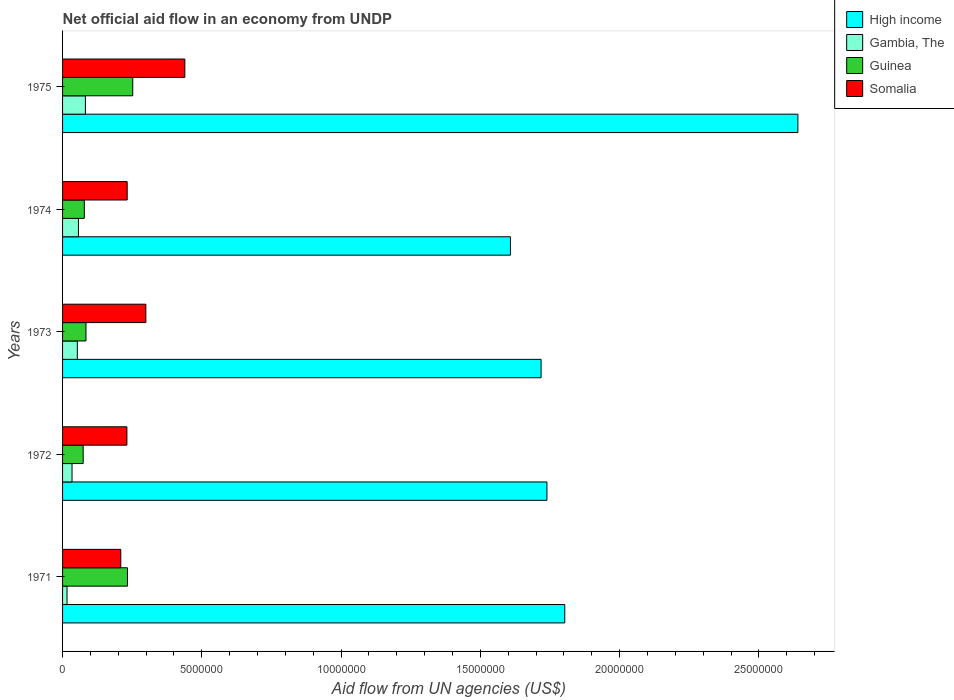How many different coloured bars are there?
Make the answer very short. 4. How many groups of bars are there?
Provide a short and direct response. 5. What is the label of the 5th group of bars from the top?
Ensure brevity in your answer.  1971. In how many cases, is the number of bars for a given year not equal to the number of legend labels?
Offer a very short reply. 0. What is the net official aid flow in Gambia, The in 1974?
Ensure brevity in your answer.  5.70e+05. Across all years, what is the maximum net official aid flow in Somalia?
Ensure brevity in your answer.  4.39e+06. Across all years, what is the minimum net official aid flow in Somalia?
Your answer should be compact. 2.09e+06. In which year was the net official aid flow in Somalia maximum?
Make the answer very short. 1975. What is the total net official aid flow in Guinea in the graph?
Keep it short and to the point. 7.21e+06. What is the difference between the net official aid flow in Guinea in 1972 and that in 1973?
Your answer should be compact. -1.00e+05. What is the difference between the net official aid flow in Somalia in 1973 and the net official aid flow in Gambia, The in 1972?
Give a very brief answer. 2.65e+06. What is the average net official aid flow in High income per year?
Keep it short and to the point. 1.90e+07. In the year 1975, what is the difference between the net official aid flow in Somalia and net official aid flow in Gambia, The?
Offer a very short reply. 3.57e+06. In how many years, is the net official aid flow in Gambia, The greater than 2000000 US$?
Keep it short and to the point. 0. What is the ratio of the net official aid flow in High income in 1972 to that in 1974?
Provide a short and direct response. 1.08. Is the net official aid flow in Guinea in 1972 less than that in 1973?
Make the answer very short. Yes. What is the difference between the highest and the second highest net official aid flow in Somalia?
Your answer should be very brief. 1.40e+06. What is the difference between the highest and the lowest net official aid flow in Gambia, The?
Give a very brief answer. 6.60e+05. Is the sum of the net official aid flow in Gambia, The in 1971 and 1972 greater than the maximum net official aid flow in Somalia across all years?
Offer a terse response. No. Is it the case that in every year, the sum of the net official aid flow in Gambia, The and net official aid flow in High income is greater than the sum of net official aid flow in Guinea and net official aid flow in Somalia?
Your response must be concise. Yes. What does the 3rd bar from the top in 1975 represents?
Your answer should be compact. Gambia, The. What does the 3rd bar from the bottom in 1973 represents?
Your answer should be compact. Guinea. Are all the bars in the graph horizontal?
Give a very brief answer. Yes. What is the difference between two consecutive major ticks on the X-axis?
Ensure brevity in your answer.  5.00e+06. Are the values on the major ticks of X-axis written in scientific E-notation?
Offer a very short reply. No. Does the graph contain any zero values?
Provide a short and direct response. No. What is the title of the graph?
Your answer should be very brief. Net official aid flow in an economy from UNDP. What is the label or title of the X-axis?
Provide a succinct answer. Aid flow from UN agencies (US$). What is the Aid flow from UN agencies (US$) of High income in 1971?
Provide a succinct answer. 1.80e+07. What is the Aid flow from UN agencies (US$) in Guinea in 1971?
Your answer should be compact. 2.33e+06. What is the Aid flow from UN agencies (US$) of Somalia in 1971?
Provide a short and direct response. 2.09e+06. What is the Aid flow from UN agencies (US$) of High income in 1972?
Offer a terse response. 1.74e+07. What is the Aid flow from UN agencies (US$) in Guinea in 1972?
Give a very brief answer. 7.40e+05. What is the Aid flow from UN agencies (US$) in Somalia in 1972?
Provide a succinct answer. 2.31e+06. What is the Aid flow from UN agencies (US$) in High income in 1973?
Your answer should be very brief. 1.72e+07. What is the Aid flow from UN agencies (US$) of Gambia, The in 1973?
Give a very brief answer. 5.30e+05. What is the Aid flow from UN agencies (US$) in Guinea in 1973?
Give a very brief answer. 8.40e+05. What is the Aid flow from UN agencies (US$) in Somalia in 1973?
Your answer should be compact. 2.99e+06. What is the Aid flow from UN agencies (US$) in High income in 1974?
Ensure brevity in your answer.  1.61e+07. What is the Aid flow from UN agencies (US$) of Gambia, The in 1974?
Offer a very short reply. 5.70e+05. What is the Aid flow from UN agencies (US$) of Guinea in 1974?
Give a very brief answer. 7.80e+05. What is the Aid flow from UN agencies (US$) of Somalia in 1974?
Offer a very short reply. 2.32e+06. What is the Aid flow from UN agencies (US$) in High income in 1975?
Offer a terse response. 2.64e+07. What is the Aid flow from UN agencies (US$) of Gambia, The in 1975?
Ensure brevity in your answer.  8.20e+05. What is the Aid flow from UN agencies (US$) of Guinea in 1975?
Keep it short and to the point. 2.52e+06. What is the Aid flow from UN agencies (US$) in Somalia in 1975?
Your answer should be very brief. 4.39e+06. Across all years, what is the maximum Aid flow from UN agencies (US$) in High income?
Give a very brief answer. 2.64e+07. Across all years, what is the maximum Aid flow from UN agencies (US$) in Gambia, The?
Provide a succinct answer. 8.20e+05. Across all years, what is the maximum Aid flow from UN agencies (US$) in Guinea?
Provide a short and direct response. 2.52e+06. Across all years, what is the maximum Aid flow from UN agencies (US$) in Somalia?
Offer a very short reply. 4.39e+06. Across all years, what is the minimum Aid flow from UN agencies (US$) in High income?
Make the answer very short. 1.61e+07. Across all years, what is the minimum Aid flow from UN agencies (US$) of Guinea?
Give a very brief answer. 7.40e+05. Across all years, what is the minimum Aid flow from UN agencies (US$) of Somalia?
Ensure brevity in your answer.  2.09e+06. What is the total Aid flow from UN agencies (US$) of High income in the graph?
Give a very brief answer. 9.51e+07. What is the total Aid flow from UN agencies (US$) of Gambia, The in the graph?
Provide a short and direct response. 2.42e+06. What is the total Aid flow from UN agencies (US$) in Guinea in the graph?
Your answer should be very brief. 7.21e+06. What is the total Aid flow from UN agencies (US$) of Somalia in the graph?
Offer a terse response. 1.41e+07. What is the difference between the Aid flow from UN agencies (US$) of High income in 1971 and that in 1972?
Your answer should be compact. 6.40e+05. What is the difference between the Aid flow from UN agencies (US$) of Guinea in 1971 and that in 1972?
Your answer should be very brief. 1.59e+06. What is the difference between the Aid flow from UN agencies (US$) of Somalia in 1971 and that in 1972?
Your answer should be very brief. -2.20e+05. What is the difference between the Aid flow from UN agencies (US$) of High income in 1971 and that in 1973?
Offer a very short reply. 8.50e+05. What is the difference between the Aid flow from UN agencies (US$) of Gambia, The in 1971 and that in 1973?
Your answer should be compact. -3.70e+05. What is the difference between the Aid flow from UN agencies (US$) in Guinea in 1971 and that in 1973?
Your answer should be very brief. 1.49e+06. What is the difference between the Aid flow from UN agencies (US$) in Somalia in 1971 and that in 1973?
Your answer should be very brief. -9.00e+05. What is the difference between the Aid flow from UN agencies (US$) in High income in 1971 and that in 1974?
Your response must be concise. 1.95e+06. What is the difference between the Aid flow from UN agencies (US$) of Gambia, The in 1971 and that in 1974?
Offer a very short reply. -4.10e+05. What is the difference between the Aid flow from UN agencies (US$) in Guinea in 1971 and that in 1974?
Provide a succinct answer. 1.55e+06. What is the difference between the Aid flow from UN agencies (US$) in High income in 1971 and that in 1975?
Keep it short and to the point. -8.37e+06. What is the difference between the Aid flow from UN agencies (US$) of Gambia, The in 1971 and that in 1975?
Make the answer very short. -6.60e+05. What is the difference between the Aid flow from UN agencies (US$) of Guinea in 1971 and that in 1975?
Your response must be concise. -1.90e+05. What is the difference between the Aid flow from UN agencies (US$) in Somalia in 1971 and that in 1975?
Keep it short and to the point. -2.30e+06. What is the difference between the Aid flow from UN agencies (US$) of High income in 1972 and that in 1973?
Give a very brief answer. 2.10e+05. What is the difference between the Aid flow from UN agencies (US$) of Gambia, The in 1972 and that in 1973?
Make the answer very short. -1.90e+05. What is the difference between the Aid flow from UN agencies (US$) in Guinea in 1972 and that in 1973?
Give a very brief answer. -1.00e+05. What is the difference between the Aid flow from UN agencies (US$) in Somalia in 1972 and that in 1973?
Your answer should be compact. -6.80e+05. What is the difference between the Aid flow from UN agencies (US$) in High income in 1972 and that in 1974?
Offer a terse response. 1.31e+06. What is the difference between the Aid flow from UN agencies (US$) of Gambia, The in 1972 and that in 1974?
Offer a very short reply. -2.30e+05. What is the difference between the Aid flow from UN agencies (US$) of Guinea in 1972 and that in 1974?
Your answer should be compact. -4.00e+04. What is the difference between the Aid flow from UN agencies (US$) of Somalia in 1972 and that in 1974?
Make the answer very short. -10000. What is the difference between the Aid flow from UN agencies (US$) in High income in 1972 and that in 1975?
Give a very brief answer. -9.01e+06. What is the difference between the Aid flow from UN agencies (US$) of Gambia, The in 1972 and that in 1975?
Your answer should be compact. -4.80e+05. What is the difference between the Aid flow from UN agencies (US$) of Guinea in 1972 and that in 1975?
Ensure brevity in your answer.  -1.78e+06. What is the difference between the Aid flow from UN agencies (US$) in Somalia in 1972 and that in 1975?
Your answer should be very brief. -2.08e+06. What is the difference between the Aid flow from UN agencies (US$) of High income in 1973 and that in 1974?
Ensure brevity in your answer.  1.10e+06. What is the difference between the Aid flow from UN agencies (US$) in Gambia, The in 1973 and that in 1974?
Offer a terse response. -4.00e+04. What is the difference between the Aid flow from UN agencies (US$) of Guinea in 1973 and that in 1974?
Give a very brief answer. 6.00e+04. What is the difference between the Aid flow from UN agencies (US$) in Somalia in 1973 and that in 1974?
Ensure brevity in your answer.  6.70e+05. What is the difference between the Aid flow from UN agencies (US$) in High income in 1973 and that in 1975?
Provide a succinct answer. -9.22e+06. What is the difference between the Aid flow from UN agencies (US$) of Guinea in 1973 and that in 1975?
Provide a short and direct response. -1.68e+06. What is the difference between the Aid flow from UN agencies (US$) of Somalia in 1973 and that in 1975?
Give a very brief answer. -1.40e+06. What is the difference between the Aid flow from UN agencies (US$) of High income in 1974 and that in 1975?
Your answer should be very brief. -1.03e+07. What is the difference between the Aid flow from UN agencies (US$) of Guinea in 1974 and that in 1975?
Give a very brief answer. -1.74e+06. What is the difference between the Aid flow from UN agencies (US$) in Somalia in 1974 and that in 1975?
Ensure brevity in your answer.  -2.07e+06. What is the difference between the Aid flow from UN agencies (US$) of High income in 1971 and the Aid flow from UN agencies (US$) of Gambia, The in 1972?
Your response must be concise. 1.77e+07. What is the difference between the Aid flow from UN agencies (US$) of High income in 1971 and the Aid flow from UN agencies (US$) of Guinea in 1972?
Provide a succinct answer. 1.73e+07. What is the difference between the Aid flow from UN agencies (US$) of High income in 1971 and the Aid flow from UN agencies (US$) of Somalia in 1972?
Provide a succinct answer. 1.57e+07. What is the difference between the Aid flow from UN agencies (US$) of Gambia, The in 1971 and the Aid flow from UN agencies (US$) of Guinea in 1972?
Your response must be concise. -5.80e+05. What is the difference between the Aid flow from UN agencies (US$) in Gambia, The in 1971 and the Aid flow from UN agencies (US$) in Somalia in 1972?
Make the answer very short. -2.15e+06. What is the difference between the Aid flow from UN agencies (US$) of Guinea in 1971 and the Aid flow from UN agencies (US$) of Somalia in 1972?
Your answer should be compact. 2.00e+04. What is the difference between the Aid flow from UN agencies (US$) in High income in 1971 and the Aid flow from UN agencies (US$) in Gambia, The in 1973?
Provide a short and direct response. 1.75e+07. What is the difference between the Aid flow from UN agencies (US$) in High income in 1971 and the Aid flow from UN agencies (US$) in Guinea in 1973?
Make the answer very short. 1.72e+07. What is the difference between the Aid flow from UN agencies (US$) of High income in 1971 and the Aid flow from UN agencies (US$) of Somalia in 1973?
Offer a terse response. 1.50e+07. What is the difference between the Aid flow from UN agencies (US$) in Gambia, The in 1971 and the Aid flow from UN agencies (US$) in Guinea in 1973?
Ensure brevity in your answer.  -6.80e+05. What is the difference between the Aid flow from UN agencies (US$) of Gambia, The in 1971 and the Aid flow from UN agencies (US$) of Somalia in 1973?
Your answer should be very brief. -2.83e+06. What is the difference between the Aid flow from UN agencies (US$) in Guinea in 1971 and the Aid flow from UN agencies (US$) in Somalia in 1973?
Ensure brevity in your answer.  -6.60e+05. What is the difference between the Aid flow from UN agencies (US$) of High income in 1971 and the Aid flow from UN agencies (US$) of Gambia, The in 1974?
Offer a terse response. 1.75e+07. What is the difference between the Aid flow from UN agencies (US$) of High income in 1971 and the Aid flow from UN agencies (US$) of Guinea in 1974?
Your answer should be compact. 1.72e+07. What is the difference between the Aid flow from UN agencies (US$) of High income in 1971 and the Aid flow from UN agencies (US$) of Somalia in 1974?
Provide a succinct answer. 1.57e+07. What is the difference between the Aid flow from UN agencies (US$) in Gambia, The in 1971 and the Aid flow from UN agencies (US$) in Guinea in 1974?
Provide a succinct answer. -6.20e+05. What is the difference between the Aid flow from UN agencies (US$) of Gambia, The in 1971 and the Aid flow from UN agencies (US$) of Somalia in 1974?
Provide a succinct answer. -2.16e+06. What is the difference between the Aid flow from UN agencies (US$) of High income in 1971 and the Aid flow from UN agencies (US$) of Gambia, The in 1975?
Your answer should be very brief. 1.72e+07. What is the difference between the Aid flow from UN agencies (US$) of High income in 1971 and the Aid flow from UN agencies (US$) of Guinea in 1975?
Offer a very short reply. 1.55e+07. What is the difference between the Aid flow from UN agencies (US$) of High income in 1971 and the Aid flow from UN agencies (US$) of Somalia in 1975?
Make the answer very short. 1.36e+07. What is the difference between the Aid flow from UN agencies (US$) of Gambia, The in 1971 and the Aid flow from UN agencies (US$) of Guinea in 1975?
Keep it short and to the point. -2.36e+06. What is the difference between the Aid flow from UN agencies (US$) in Gambia, The in 1971 and the Aid flow from UN agencies (US$) in Somalia in 1975?
Provide a succinct answer. -4.23e+06. What is the difference between the Aid flow from UN agencies (US$) of Guinea in 1971 and the Aid flow from UN agencies (US$) of Somalia in 1975?
Your answer should be compact. -2.06e+06. What is the difference between the Aid flow from UN agencies (US$) of High income in 1972 and the Aid flow from UN agencies (US$) of Gambia, The in 1973?
Your response must be concise. 1.69e+07. What is the difference between the Aid flow from UN agencies (US$) of High income in 1972 and the Aid flow from UN agencies (US$) of Guinea in 1973?
Provide a succinct answer. 1.66e+07. What is the difference between the Aid flow from UN agencies (US$) in High income in 1972 and the Aid flow from UN agencies (US$) in Somalia in 1973?
Offer a very short reply. 1.44e+07. What is the difference between the Aid flow from UN agencies (US$) of Gambia, The in 1972 and the Aid flow from UN agencies (US$) of Guinea in 1973?
Keep it short and to the point. -5.00e+05. What is the difference between the Aid flow from UN agencies (US$) in Gambia, The in 1972 and the Aid flow from UN agencies (US$) in Somalia in 1973?
Provide a succinct answer. -2.65e+06. What is the difference between the Aid flow from UN agencies (US$) of Guinea in 1972 and the Aid flow from UN agencies (US$) of Somalia in 1973?
Your answer should be very brief. -2.25e+06. What is the difference between the Aid flow from UN agencies (US$) in High income in 1972 and the Aid flow from UN agencies (US$) in Gambia, The in 1974?
Give a very brief answer. 1.68e+07. What is the difference between the Aid flow from UN agencies (US$) in High income in 1972 and the Aid flow from UN agencies (US$) in Guinea in 1974?
Provide a short and direct response. 1.66e+07. What is the difference between the Aid flow from UN agencies (US$) in High income in 1972 and the Aid flow from UN agencies (US$) in Somalia in 1974?
Your answer should be very brief. 1.51e+07. What is the difference between the Aid flow from UN agencies (US$) of Gambia, The in 1972 and the Aid flow from UN agencies (US$) of Guinea in 1974?
Your response must be concise. -4.40e+05. What is the difference between the Aid flow from UN agencies (US$) of Gambia, The in 1972 and the Aid flow from UN agencies (US$) of Somalia in 1974?
Make the answer very short. -1.98e+06. What is the difference between the Aid flow from UN agencies (US$) of Guinea in 1972 and the Aid flow from UN agencies (US$) of Somalia in 1974?
Make the answer very short. -1.58e+06. What is the difference between the Aid flow from UN agencies (US$) in High income in 1972 and the Aid flow from UN agencies (US$) in Gambia, The in 1975?
Provide a succinct answer. 1.66e+07. What is the difference between the Aid flow from UN agencies (US$) in High income in 1972 and the Aid flow from UN agencies (US$) in Guinea in 1975?
Provide a succinct answer. 1.49e+07. What is the difference between the Aid flow from UN agencies (US$) of High income in 1972 and the Aid flow from UN agencies (US$) of Somalia in 1975?
Your answer should be very brief. 1.30e+07. What is the difference between the Aid flow from UN agencies (US$) in Gambia, The in 1972 and the Aid flow from UN agencies (US$) in Guinea in 1975?
Provide a short and direct response. -2.18e+06. What is the difference between the Aid flow from UN agencies (US$) in Gambia, The in 1972 and the Aid flow from UN agencies (US$) in Somalia in 1975?
Offer a terse response. -4.05e+06. What is the difference between the Aid flow from UN agencies (US$) of Guinea in 1972 and the Aid flow from UN agencies (US$) of Somalia in 1975?
Keep it short and to the point. -3.65e+06. What is the difference between the Aid flow from UN agencies (US$) of High income in 1973 and the Aid flow from UN agencies (US$) of Gambia, The in 1974?
Offer a terse response. 1.66e+07. What is the difference between the Aid flow from UN agencies (US$) in High income in 1973 and the Aid flow from UN agencies (US$) in Guinea in 1974?
Ensure brevity in your answer.  1.64e+07. What is the difference between the Aid flow from UN agencies (US$) of High income in 1973 and the Aid flow from UN agencies (US$) of Somalia in 1974?
Your response must be concise. 1.49e+07. What is the difference between the Aid flow from UN agencies (US$) of Gambia, The in 1973 and the Aid flow from UN agencies (US$) of Guinea in 1974?
Ensure brevity in your answer.  -2.50e+05. What is the difference between the Aid flow from UN agencies (US$) in Gambia, The in 1973 and the Aid flow from UN agencies (US$) in Somalia in 1974?
Offer a very short reply. -1.79e+06. What is the difference between the Aid flow from UN agencies (US$) in Guinea in 1973 and the Aid flow from UN agencies (US$) in Somalia in 1974?
Your answer should be very brief. -1.48e+06. What is the difference between the Aid flow from UN agencies (US$) of High income in 1973 and the Aid flow from UN agencies (US$) of Gambia, The in 1975?
Offer a very short reply. 1.64e+07. What is the difference between the Aid flow from UN agencies (US$) of High income in 1973 and the Aid flow from UN agencies (US$) of Guinea in 1975?
Give a very brief answer. 1.47e+07. What is the difference between the Aid flow from UN agencies (US$) in High income in 1973 and the Aid flow from UN agencies (US$) in Somalia in 1975?
Make the answer very short. 1.28e+07. What is the difference between the Aid flow from UN agencies (US$) in Gambia, The in 1973 and the Aid flow from UN agencies (US$) in Guinea in 1975?
Your answer should be compact. -1.99e+06. What is the difference between the Aid flow from UN agencies (US$) of Gambia, The in 1973 and the Aid flow from UN agencies (US$) of Somalia in 1975?
Your answer should be very brief. -3.86e+06. What is the difference between the Aid flow from UN agencies (US$) in Guinea in 1973 and the Aid flow from UN agencies (US$) in Somalia in 1975?
Your answer should be very brief. -3.55e+06. What is the difference between the Aid flow from UN agencies (US$) in High income in 1974 and the Aid flow from UN agencies (US$) in Gambia, The in 1975?
Your response must be concise. 1.53e+07. What is the difference between the Aid flow from UN agencies (US$) of High income in 1974 and the Aid flow from UN agencies (US$) of Guinea in 1975?
Your response must be concise. 1.36e+07. What is the difference between the Aid flow from UN agencies (US$) in High income in 1974 and the Aid flow from UN agencies (US$) in Somalia in 1975?
Make the answer very short. 1.17e+07. What is the difference between the Aid flow from UN agencies (US$) in Gambia, The in 1974 and the Aid flow from UN agencies (US$) in Guinea in 1975?
Your response must be concise. -1.95e+06. What is the difference between the Aid flow from UN agencies (US$) of Gambia, The in 1974 and the Aid flow from UN agencies (US$) of Somalia in 1975?
Make the answer very short. -3.82e+06. What is the difference between the Aid flow from UN agencies (US$) of Guinea in 1974 and the Aid flow from UN agencies (US$) of Somalia in 1975?
Offer a very short reply. -3.61e+06. What is the average Aid flow from UN agencies (US$) of High income per year?
Keep it short and to the point. 1.90e+07. What is the average Aid flow from UN agencies (US$) of Gambia, The per year?
Provide a short and direct response. 4.84e+05. What is the average Aid flow from UN agencies (US$) of Guinea per year?
Give a very brief answer. 1.44e+06. What is the average Aid flow from UN agencies (US$) in Somalia per year?
Provide a short and direct response. 2.82e+06. In the year 1971, what is the difference between the Aid flow from UN agencies (US$) of High income and Aid flow from UN agencies (US$) of Gambia, The?
Offer a terse response. 1.79e+07. In the year 1971, what is the difference between the Aid flow from UN agencies (US$) in High income and Aid flow from UN agencies (US$) in Guinea?
Provide a short and direct response. 1.57e+07. In the year 1971, what is the difference between the Aid flow from UN agencies (US$) of High income and Aid flow from UN agencies (US$) of Somalia?
Provide a succinct answer. 1.59e+07. In the year 1971, what is the difference between the Aid flow from UN agencies (US$) of Gambia, The and Aid flow from UN agencies (US$) of Guinea?
Your answer should be compact. -2.17e+06. In the year 1971, what is the difference between the Aid flow from UN agencies (US$) of Gambia, The and Aid flow from UN agencies (US$) of Somalia?
Ensure brevity in your answer.  -1.93e+06. In the year 1972, what is the difference between the Aid flow from UN agencies (US$) of High income and Aid flow from UN agencies (US$) of Gambia, The?
Keep it short and to the point. 1.70e+07. In the year 1972, what is the difference between the Aid flow from UN agencies (US$) in High income and Aid flow from UN agencies (US$) in Guinea?
Provide a short and direct response. 1.66e+07. In the year 1972, what is the difference between the Aid flow from UN agencies (US$) of High income and Aid flow from UN agencies (US$) of Somalia?
Your response must be concise. 1.51e+07. In the year 1972, what is the difference between the Aid flow from UN agencies (US$) of Gambia, The and Aid flow from UN agencies (US$) of Guinea?
Make the answer very short. -4.00e+05. In the year 1972, what is the difference between the Aid flow from UN agencies (US$) in Gambia, The and Aid flow from UN agencies (US$) in Somalia?
Offer a very short reply. -1.97e+06. In the year 1972, what is the difference between the Aid flow from UN agencies (US$) in Guinea and Aid flow from UN agencies (US$) in Somalia?
Offer a terse response. -1.57e+06. In the year 1973, what is the difference between the Aid flow from UN agencies (US$) in High income and Aid flow from UN agencies (US$) in Gambia, The?
Give a very brief answer. 1.66e+07. In the year 1973, what is the difference between the Aid flow from UN agencies (US$) of High income and Aid flow from UN agencies (US$) of Guinea?
Your response must be concise. 1.63e+07. In the year 1973, what is the difference between the Aid flow from UN agencies (US$) in High income and Aid flow from UN agencies (US$) in Somalia?
Provide a short and direct response. 1.42e+07. In the year 1973, what is the difference between the Aid flow from UN agencies (US$) of Gambia, The and Aid flow from UN agencies (US$) of Guinea?
Offer a terse response. -3.10e+05. In the year 1973, what is the difference between the Aid flow from UN agencies (US$) of Gambia, The and Aid flow from UN agencies (US$) of Somalia?
Your response must be concise. -2.46e+06. In the year 1973, what is the difference between the Aid flow from UN agencies (US$) of Guinea and Aid flow from UN agencies (US$) of Somalia?
Give a very brief answer. -2.15e+06. In the year 1974, what is the difference between the Aid flow from UN agencies (US$) of High income and Aid flow from UN agencies (US$) of Gambia, The?
Keep it short and to the point. 1.55e+07. In the year 1974, what is the difference between the Aid flow from UN agencies (US$) of High income and Aid flow from UN agencies (US$) of Guinea?
Provide a succinct answer. 1.53e+07. In the year 1974, what is the difference between the Aid flow from UN agencies (US$) in High income and Aid flow from UN agencies (US$) in Somalia?
Your response must be concise. 1.38e+07. In the year 1974, what is the difference between the Aid flow from UN agencies (US$) of Gambia, The and Aid flow from UN agencies (US$) of Somalia?
Give a very brief answer. -1.75e+06. In the year 1974, what is the difference between the Aid flow from UN agencies (US$) in Guinea and Aid flow from UN agencies (US$) in Somalia?
Your answer should be compact. -1.54e+06. In the year 1975, what is the difference between the Aid flow from UN agencies (US$) in High income and Aid flow from UN agencies (US$) in Gambia, The?
Provide a succinct answer. 2.56e+07. In the year 1975, what is the difference between the Aid flow from UN agencies (US$) in High income and Aid flow from UN agencies (US$) in Guinea?
Keep it short and to the point. 2.39e+07. In the year 1975, what is the difference between the Aid flow from UN agencies (US$) of High income and Aid flow from UN agencies (US$) of Somalia?
Your answer should be very brief. 2.20e+07. In the year 1975, what is the difference between the Aid flow from UN agencies (US$) in Gambia, The and Aid flow from UN agencies (US$) in Guinea?
Offer a terse response. -1.70e+06. In the year 1975, what is the difference between the Aid flow from UN agencies (US$) of Gambia, The and Aid flow from UN agencies (US$) of Somalia?
Ensure brevity in your answer.  -3.57e+06. In the year 1975, what is the difference between the Aid flow from UN agencies (US$) in Guinea and Aid flow from UN agencies (US$) in Somalia?
Give a very brief answer. -1.87e+06. What is the ratio of the Aid flow from UN agencies (US$) in High income in 1971 to that in 1972?
Offer a very short reply. 1.04. What is the ratio of the Aid flow from UN agencies (US$) of Gambia, The in 1971 to that in 1972?
Your answer should be compact. 0.47. What is the ratio of the Aid flow from UN agencies (US$) of Guinea in 1971 to that in 1972?
Keep it short and to the point. 3.15. What is the ratio of the Aid flow from UN agencies (US$) in Somalia in 1971 to that in 1972?
Give a very brief answer. 0.9. What is the ratio of the Aid flow from UN agencies (US$) of High income in 1971 to that in 1973?
Your answer should be very brief. 1.05. What is the ratio of the Aid flow from UN agencies (US$) in Gambia, The in 1971 to that in 1973?
Ensure brevity in your answer.  0.3. What is the ratio of the Aid flow from UN agencies (US$) of Guinea in 1971 to that in 1973?
Give a very brief answer. 2.77. What is the ratio of the Aid flow from UN agencies (US$) of Somalia in 1971 to that in 1973?
Ensure brevity in your answer.  0.7. What is the ratio of the Aid flow from UN agencies (US$) in High income in 1971 to that in 1974?
Ensure brevity in your answer.  1.12. What is the ratio of the Aid flow from UN agencies (US$) of Gambia, The in 1971 to that in 1974?
Your answer should be compact. 0.28. What is the ratio of the Aid flow from UN agencies (US$) of Guinea in 1971 to that in 1974?
Provide a short and direct response. 2.99. What is the ratio of the Aid flow from UN agencies (US$) in Somalia in 1971 to that in 1974?
Offer a terse response. 0.9. What is the ratio of the Aid flow from UN agencies (US$) in High income in 1971 to that in 1975?
Your answer should be compact. 0.68. What is the ratio of the Aid flow from UN agencies (US$) of Gambia, The in 1971 to that in 1975?
Offer a terse response. 0.2. What is the ratio of the Aid flow from UN agencies (US$) of Guinea in 1971 to that in 1975?
Give a very brief answer. 0.92. What is the ratio of the Aid flow from UN agencies (US$) in Somalia in 1971 to that in 1975?
Your answer should be compact. 0.48. What is the ratio of the Aid flow from UN agencies (US$) in High income in 1972 to that in 1973?
Ensure brevity in your answer.  1.01. What is the ratio of the Aid flow from UN agencies (US$) of Gambia, The in 1972 to that in 1973?
Provide a short and direct response. 0.64. What is the ratio of the Aid flow from UN agencies (US$) of Guinea in 1972 to that in 1973?
Provide a short and direct response. 0.88. What is the ratio of the Aid flow from UN agencies (US$) in Somalia in 1972 to that in 1973?
Make the answer very short. 0.77. What is the ratio of the Aid flow from UN agencies (US$) in High income in 1972 to that in 1974?
Keep it short and to the point. 1.08. What is the ratio of the Aid flow from UN agencies (US$) of Gambia, The in 1972 to that in 1974?
Offer a very short reply. 0.6. What is the ratio of the Aid flow from UN agencies (US$) in Guinea in 1972 to that in 1974?
Offer a terse response. 0.95. What is the ratio of the Aid flow from UN agencies (US$) in Somalia in 1972 to that in 1974?
Offer a terse response. 1. What is the ratio of the Aid flow from UN agencies (US$) of High income in 1972 to that in 1975?
Your response must be concise. 0.66. What is the ratio of the Aid flow from UN agencies (US$) of Gambia, The in 1972 to that in 1975?
Your answer should be compact. 0.41. What is the ratio of the Aid flow from UN agencies (US$) of Guinea in 1972 to that in 1975?
Your answer should be compact. 0.29. What is the ratio of the Aid flow from UN agencies (US$) in Somalia in 1972 to that in 1975?
Make the answer very short. 0.53. What is the ratio of the Aid flow from UN agencies (US$) in High income in 1973 to that in 1974?
Make the answer very short. 1.07. What is the ratio of the Aid flow from UN agencies (US$) of Gambia, The in 1973 to that in 1974?
Offer a very short reply. 0.93. What is the ratio of the Aid flow from UN agencies (US$) in Somalia in 1973 to that in 1974?
Ensure brevity in your answer.  1.29. What is the ratio of the Aid flow from UN agencies (US$) of High income in 1973 to that in 1975?
Make the answer very short. 0.65. What is the ratio of the Aid flow from UN agencies (US$) in Gambia, The in 1973 to that in 1975?
Give a very brief answer. 0.65. What is the ratio of the Aid flow from UN agencies (US$) of Guinea in 1973 to that in 1975?
Offer a terse response. 0.33. What is the ratio of the Aid flow from UN agencies (US$) in Somalia in 1973 to that in 1975?
Offer a very short reply. 0.68. What is the ratio of the Aid flow from UN agencies (US$) of High income in 1974 to that in 1975?
Make the answer very short. 0.61. What is the ratio of the Aid flow from UN agencies (US$) of Gambia, The in 1974 to that in 1975?
Offer a terse response. 0.7. What is the ratio of the Aid flow from UN agencies (US$) of Guinea in 1974 to that in 1975?
Provide a succinct answer. 0.31. What is the ratio of the Aid flow from UN agencies (US$) of Somalia in 1974 to that in 1975?
Make the answer very short. 0.53. What is the difference between the highest and the second highest Aid flow from UN agencies (US$) of High income?
Offer a very short reply. 8.37e+06. What is the difference between the highest and the second highest Aid flow from UN agencies (US$) of Guinea?
Make the answer very short. 1.90e+05. What is the difference between the highest and the second highest Aid flow from UN agencies (US$) of Somalia?
Your answer should be very brief. 1.40e+06. What is the difference between the highest and the lowest Aid flow from UN agencies (US$) of High income?
Provide a short and direct response. 1.03e+07. What is the difference between the highest and the lowest Aid flow from UN agencies (US$) of Gambia, The?
Make the answer very short. 6.60e+05. What is the difference between the highest and the lowest Aid flow from UN agencies (US$) in Guinea?
Provide a short and direct response. 1.78e+06. What is the difference between the highest and the lowest Aid flow from UN agencies (US$) in Somalia?
Provide a succinct answer. 2.30e+06. 